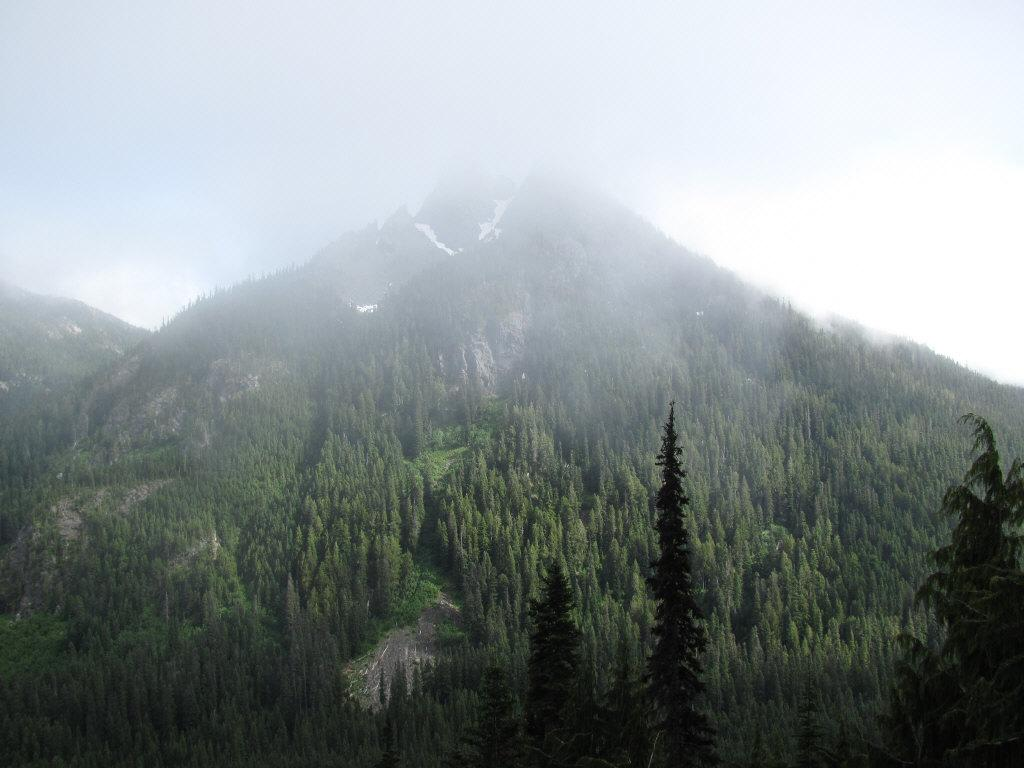What type of natural features can be seen in the image? There are trees and mountains in the image. What is visible in the background of the image? The sky is visible in the background of the image. What type of fruit is hanging from the trees in the image? There is no fruit visible on the trees in the image. 